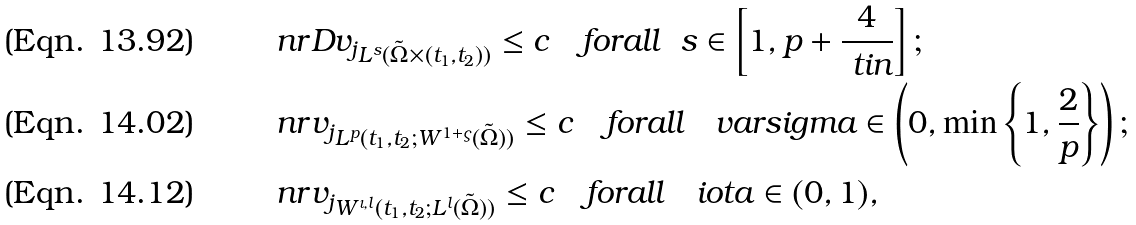Convert formula to latex. <formula><loc_0><loc_0><loc_500><loc_500>& \ n r { D v _ { j } } _ { L ^ { s } ( \tilde { \Omega } \times ( t _ { 1 } , t _ { 2 } ) ) } \leq c \quad f o r a l l \ \ s \in \left [ 1 , p + \frac { 4 } { \ t i { n } } \right ] ; \\ & \ n r { v _ { j } } _ { L ^ { p } ( t _ { 1 } , t _ { 2 } ; W ^ { 1 + \varsigma } ( \tilde { \Omega } ) ) } \leq c \quad f o r a l l \quad v a r s i g m a \in \left ( 0 , \min \left \{ 1 , \frac { 2 } { p } \right \} \right ) ; \\ & \ n r { v _ { j } } _ { W ^ { \iota , l } ( t _ { 1 } , t _ { 2 } ; L ^ { l } ( \tilde { \Omega } ) ) } \leq c \quad f o r a l l \quad i o t a \in ( 0 , 1 ) ,</formula> 